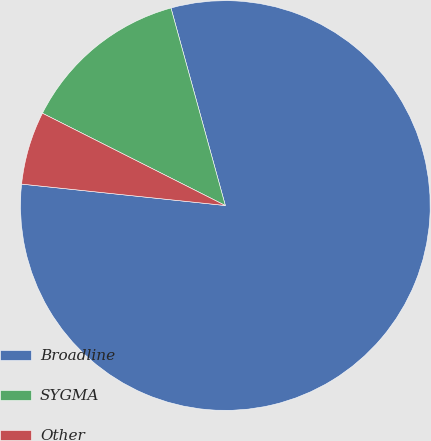Convert chart to OTSL. <chart><loc_0><loc_0><loc_500><loc_500><pie_chart><fcel>Broadline<fcel>SYGMA<fcel>Other<nl><fcel>80.95%<fcel>13.29%<fcel>5.77%<nl></chart> 